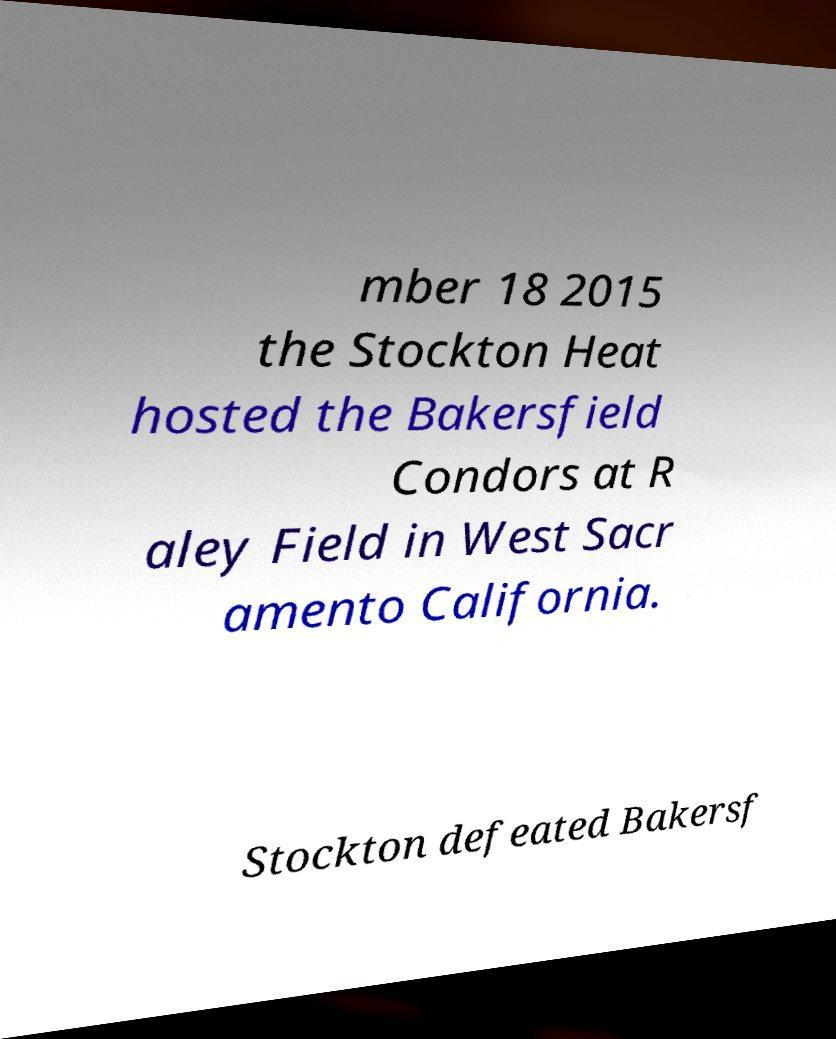What messages or text are displayed in this image? I need them in a readable, typed format. mber 18 2015 the Stockton Heat hosted the Bakersfield Condors at R aley Field in West Sacr amento California. Stockton defeated Bakersf 